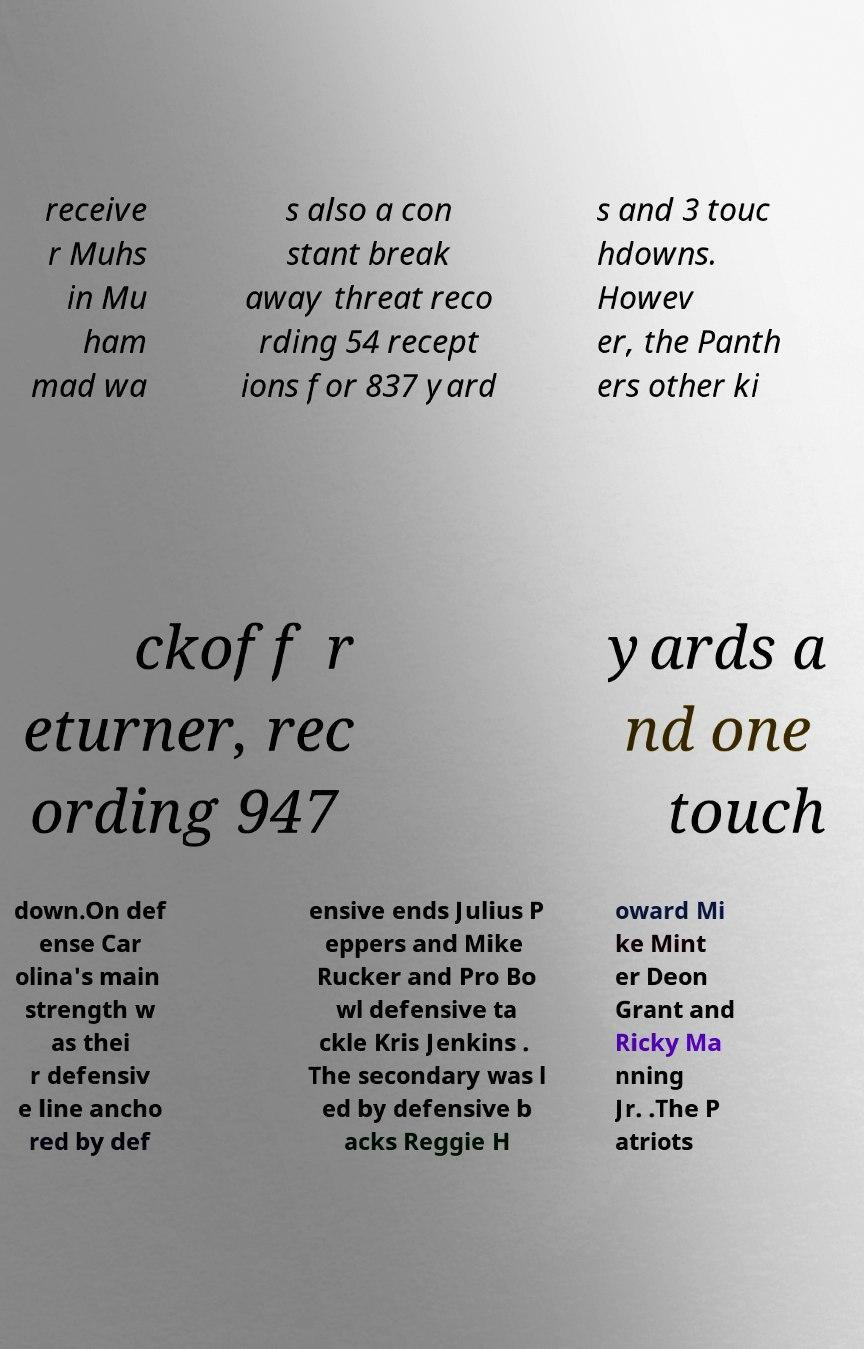Please identify and transcribe the text found in this image. receive r Muhs in Mu ham mad wa s also a con stant break away threat reco rding 54 recept ions for 837 yard s and 3 touc hdowns. Howev er, the Panth ers other ki ckoff r eturner, rec ording 947 yards a nd one touch down.On def ense Car olina's main strength w as thei r defensiv e line ancho red by def ensive ends Julius P eppers and Mike Rucker and Pro Bo wl defensive ta ckle Kris Jenkins . The secondary was l ed by defensive b acks Reggie H oward Mi ke Mint er Deon Grant and Ricky Ma nning Jr. .The P atriots 